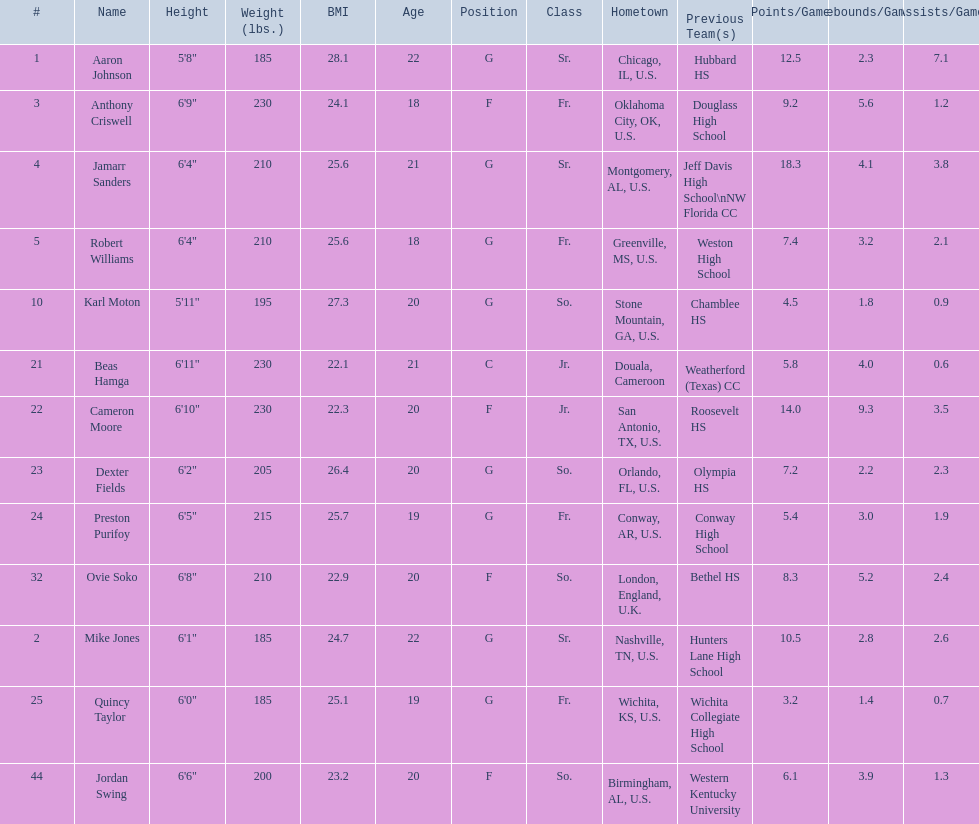Who are all the players? Aaron Johnson, Anthony Criswell, Jamarr Sanders, Robert Williams, Karl Moton, Beas Hamga, Cameron Moore, Dexter Fields, Preston Purifoy, Ovie Soko, Mike Jones, Quincy Taylor, Jordan Swing. Of these, which are not soko? Aaron Johnson, Anthony Criswell, Jamarr Sanders, Robert Williams, Karl Moton, Beas Hamga, Cameron Moore, Dexter Fields, Preston Purifoy, Mike Jones, Quincy Taylor, Jordan Swing. Where are these players from? Sr., Fr., Sr., Fr., So., Jr., Jr., So., Fr., Sr., Fr., So. Of these locations, which are not in the u.s.? Jr. Which player is from this location? Beas Hamga. 